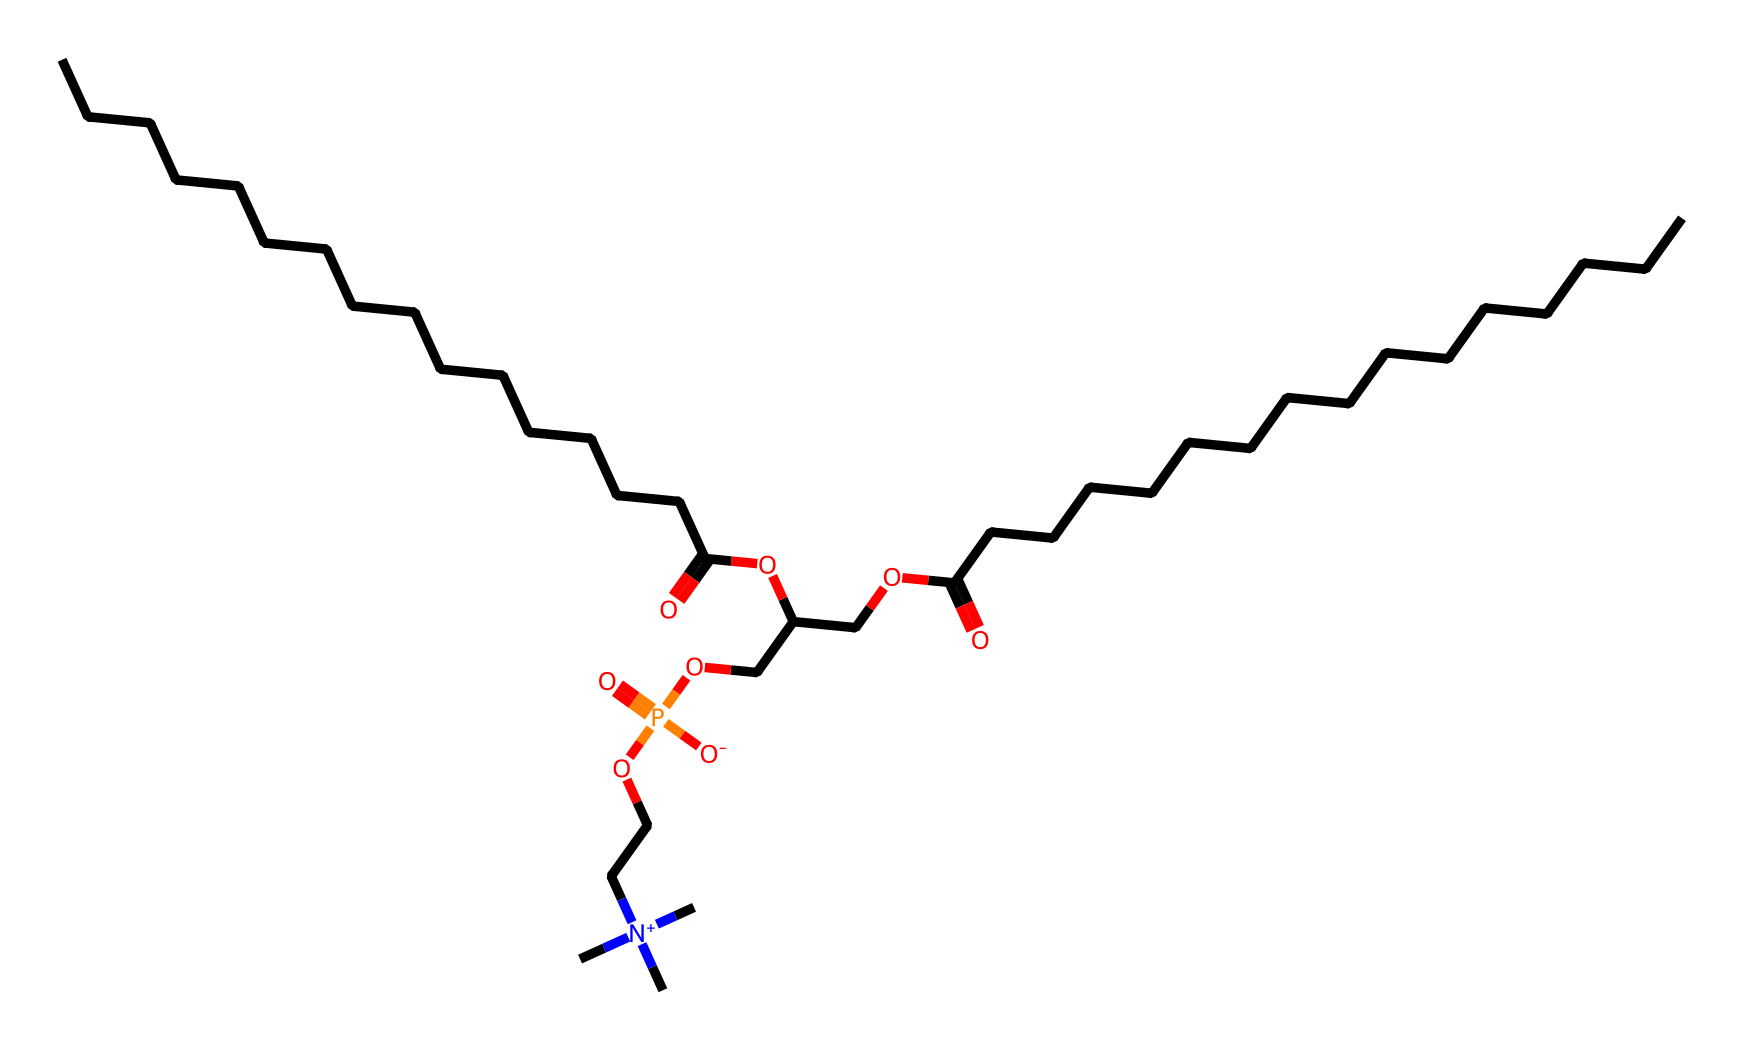how many carbon atoms are in the molecule? By examining the SMILES representation, we can count the number of 'C' characters before any parentheses or functional groups. In this chemical structure, there are 30 carbon atoms.
Answer: 30 what is the main functional group present in this compound? The presence of the -OCC- and -C(=O)O- indicates that ester groups are present in the molecule, which are characteristic of phospholipids. Thus, the main functional group is ester.
Answer: ester how many phosphorus atoms are in the structure? In the SMILES notation, the 'P' represents phosphorus. There is only one 'P' present in the entire structure, indicating that there is one phosphorus atom.
Answer: 1 what type of bonding is primarily responsible for the hydrophilic properties of this molecule? The presence of phosphate groups, as indicated by 'P(=O)([O-])', contributes to the hydrophilic nature of the compound due to the polarity of the phosphate functional group.
Answer: phosphate which part of the molecular structure provides the hydrophobic characteristics? The long hydrocarbon chains represented by multiple 'C' and 'H' atoms indicate non-polar components that contribute to hydrophobic characteristics, specifically the sections such as 'CCCCCCCCCCCCCCCC' and 'CCCCCCCCCCCCCCC'.
Answer: hydrocarbon chains how does the presence of nitrogen in the structure affect its properties? The nitrogen atom, as seen in '[N+](C)(C)C', indicates that this molecule contains a quaternary ammonium compound, which enhances the softening properties and contributes to the overall cationic character important for fabric conditioning.
Answer: cationic character what is the significance of the 'O-' in the structure? The 'O-' signifies a negatively charged oxygen atom connected to phosphorus; this is indicative of a phosphate group, which plays a key role in the bioactivity and functional properties of phospholipids.
Answer: phosphate group 